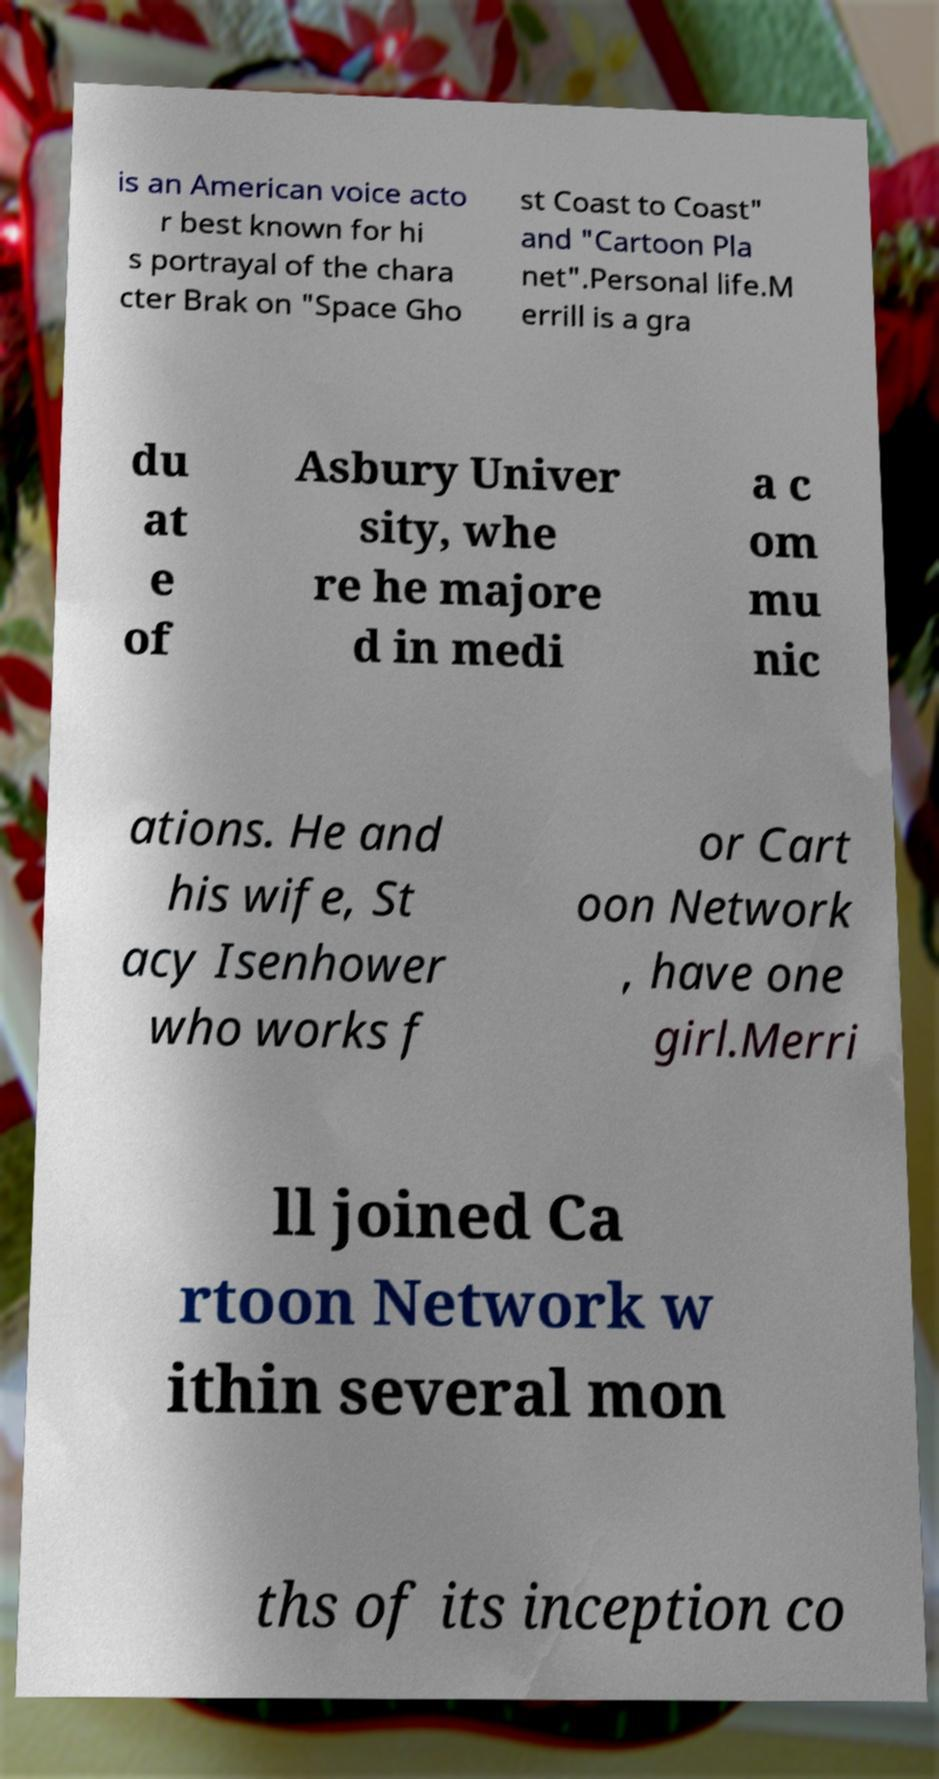There's text embedded in this image that I need extracted. Can you transcribe it verbatim? is an American voice acto r best known for hi s portrayal of the chara cter Brak on "Space Gho st Coast to Coast" and "Cartoon Pla net".Personal life.M errill is a gra du at e of Asbury Univer sity, whe re he majore d in medi a c om mu nic ations. He and his wife, St acy Isenhower who works f or Cart oon Network , have one girl.Merri ll joined Ca rtoon Network w ithin several mon ths of its inception co 